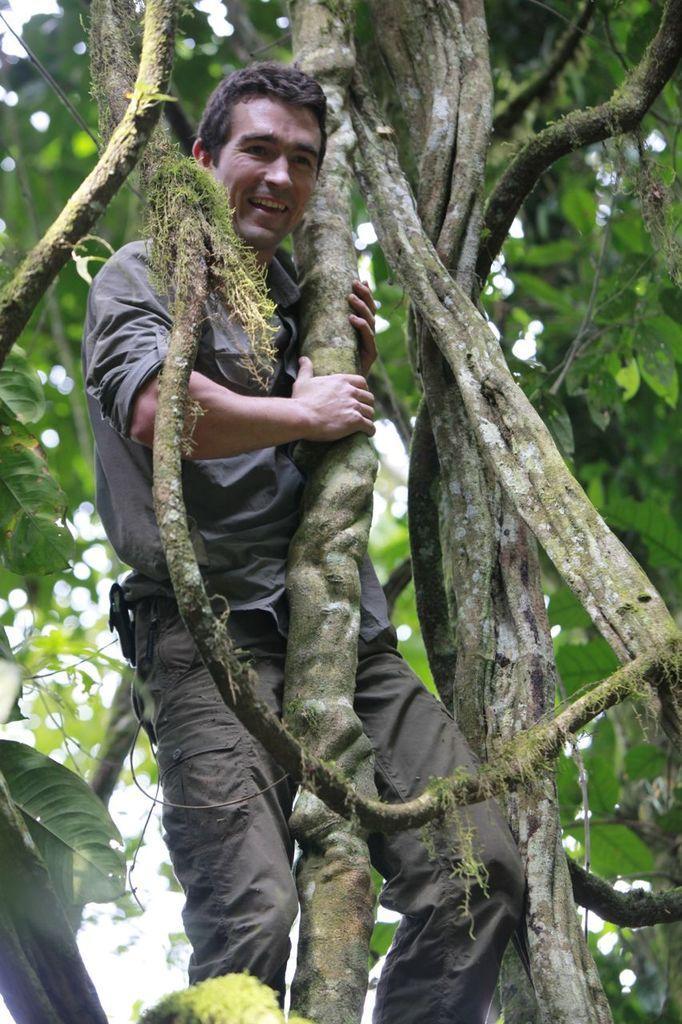Please provide a concise description of this image. There is a person standing and holding a branch of tree. 